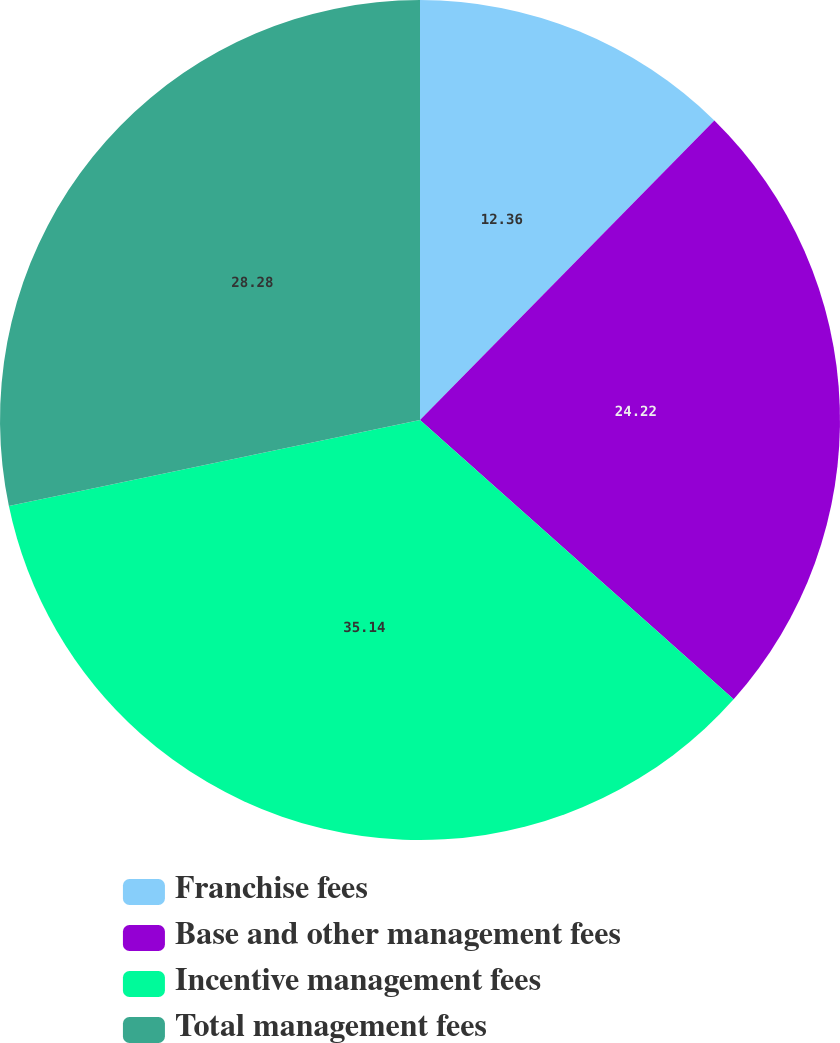Convert chart to OTSL. <chart><loc_0><loc_0><loc_500><loc_500><pie_chart><fcel>Franchise fees<fcel>Base and other management fees<fcel>Incentive management fees<fcel>Total management fees<nl><fcel>12.36%<fcel>24.22%<fcel>35.14%<fcel>28.28%<nl></chart> 